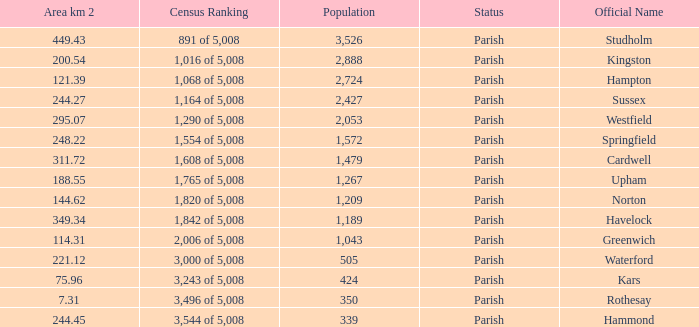What is the area in square kilometers of Studholm? 1.0. 